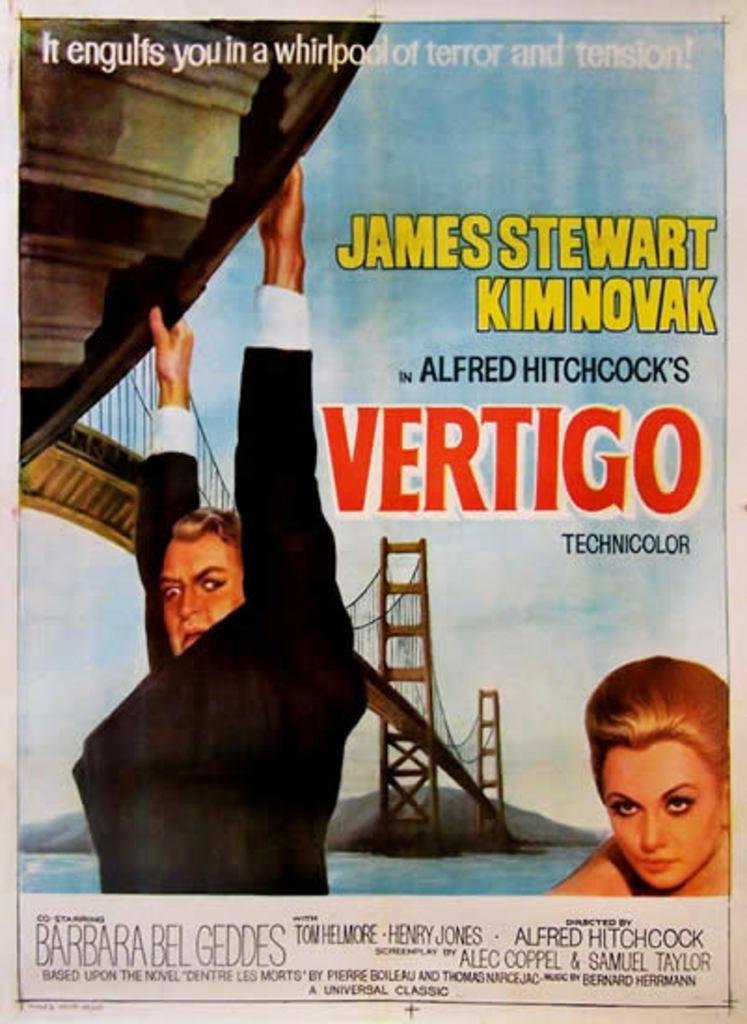<image>
Create a compact narrative representing the image presented. A flyer advertising the movie Vertigo shows a person hanging from the side of a bridge. 